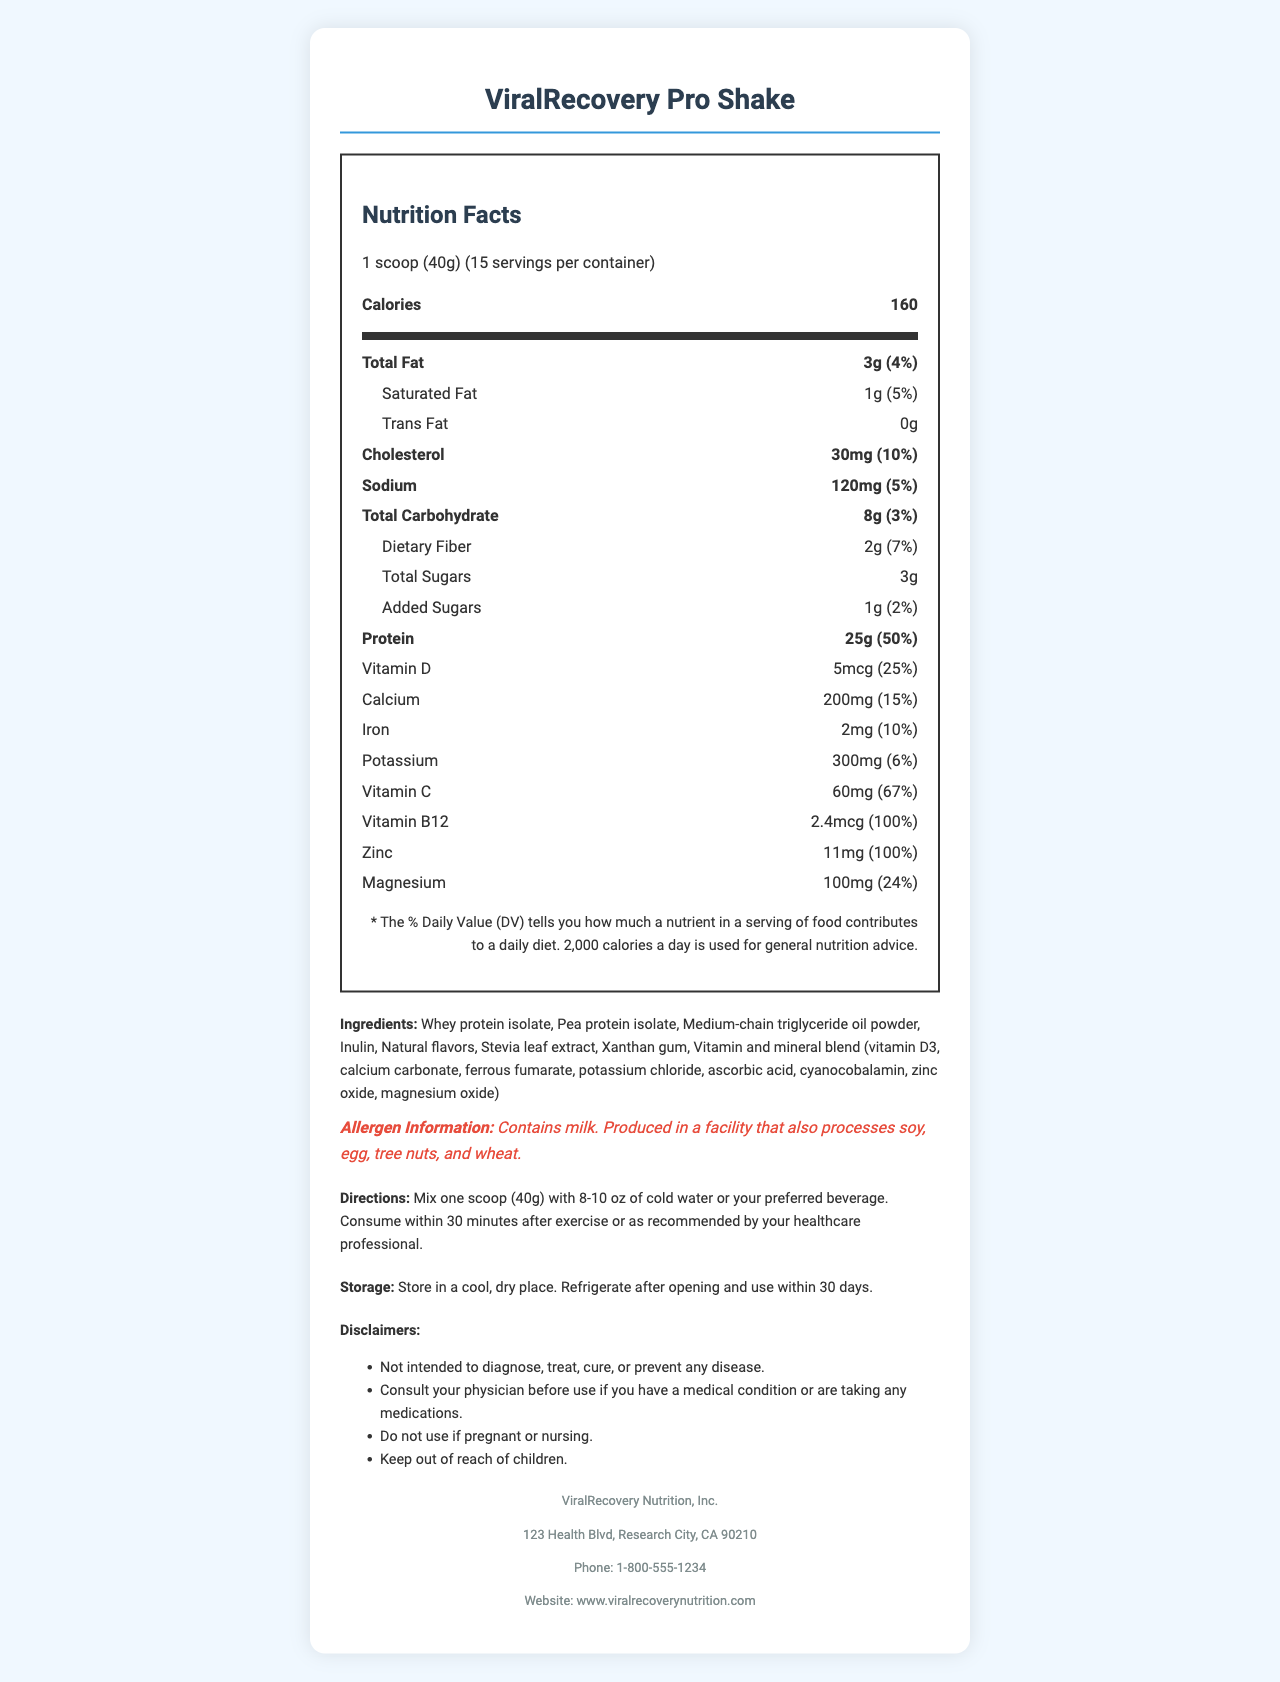what is the product name? The product name is clearly stated at the top of the document and also in the title section.
Answer: ViralRecovery Pro Shake what is the serving size? The serving size is listed right under the product name and nutrition facts title.
Answer: 1 scoop (40g) how many servings are there per container? The number of servings per container is mentioned along with the serving size right under the nutrition facts title.
Answer: 15 how many calories are in one serving? The calories per serving are prominently displayed under the nutrition facts section.
Answer: 160 how much protein is in one serving? The amount of protein per serving is listed under the nutrition facts section under the protein category.
Answer: 25g Which of the following is NOT an ingredient in ViralRecovery Pro Shake? A. Whey protein isolate B. Medium-chain triglyceride oil powder C. Soy protein isolate D. Pea protein isolate The ingredients listed are whey protein isolate, pea protein isolate, medium-chain triglyceride oil powder, inulin, natural flavors, stevia leaf extract, xanthan gum, and a vitamin and mineral blend. Soy protein isolate is not listed as an ingredient.
Answer: C What is the daily value percentage of Vitamin B12? A. 24% B. 25% C. 50% D. 100% The daily value percentage of Vitamin B12 is 100%, which is indicated under the nutrition facts section.
Answer: D Does this product contain any milk? The allergen information section clearly states that the product contains milk.
Answer: Yes How much Vitamin D is in one serving? The nutrition facts section lists the amount of Vitamin D as 5mcg per serving.
Answer: 5mcg What disclaimers are included in the document? The disclaimers are presented as a bulleted list under the disclaimers section.
Answer: Not intended to diagnose, treat, cure, or prevent any disease. Consult your physician before use if you have a medical condition or are taking any medications. Do not use if pregnant or nursing. Keep out of reach of children. Summarize the main points of this document. The main points of the document include the key nutritional information, ingredients, precautionary statements, and product usage guidelines for ViralRecovery Pro Shake.
Answer: The document contains the nutrition facts, ingredients, allergen information, directions for use, storage instructions, disclaimers, and manufacturer information for a high-protein recovery shake called ViralRecovery Pro Shake. The product has 160 calories per serving, along with various vitamins and minerals designed to assist recovery from post-viral fatigue syndrome. What is the recommended storage for the product after opening? The storage instructions clearly state that the product should be refrigerated after opening and used within 30 days.
Answer: Refrigerate after opening and use within 30 days. How much added sugars does one serving contain? Under the nutrition facts section, it indicates that the added sugars total 1g per serving.
Answer: 1g What is the daily value percentage for Iron? The nutrition facts section states that the daily value percentage for iron is 10%.
Answer: 10% How much calcium is provided in one serving? According to the nutrition facts section, each serving contains 200mg of calcium.
Answer: 200mg Where is the manufacturer's headquarters located? The manufacturer information section lists the address of ViralRecovery Nutrition, Inc.
Answer: 123 Health Blvd, Research City, CA 90210 